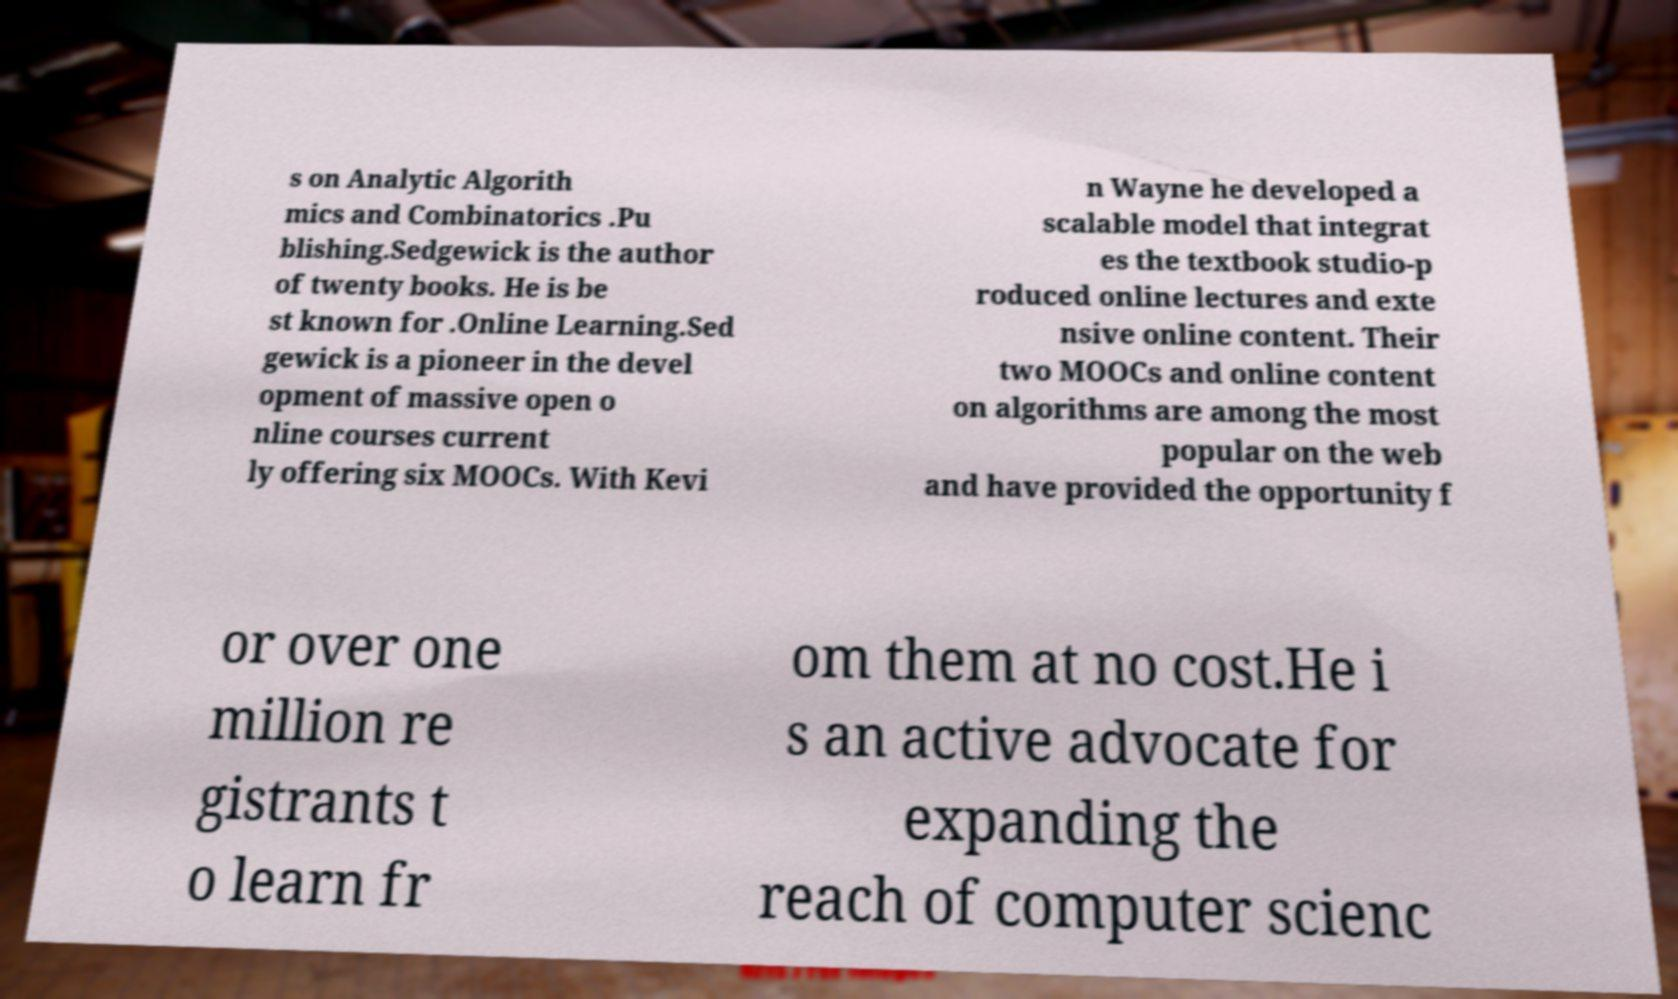I need the written content from this picture converted into text. Can you do that? s on Analytic Algorith mics and Combinatorics .Pu blishing.Sedgewick is the author of twenty books. He is be st known for .Online Learning.Sed gewick is a pioneer in the devel opment of massive open o nline courses current ly offering six MOOCs. With Kevi n Wayne he developed a scalable model that integrat es the textbook studio-p roduced online lectures and exte nsive online content. Their two MOOCs and online content on algorithms are among the most popular on the web and have provided the opportunity f or over one million re gistrants t o learn fr om them at no cost.He i s an active advocate for expanding the reach of computer scienc 